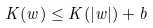Convert formula to latex. <formula><loc_0><loc_0><loc_500><loc_500>K ( w ) \leq K ( | w | ) + b</formula> 